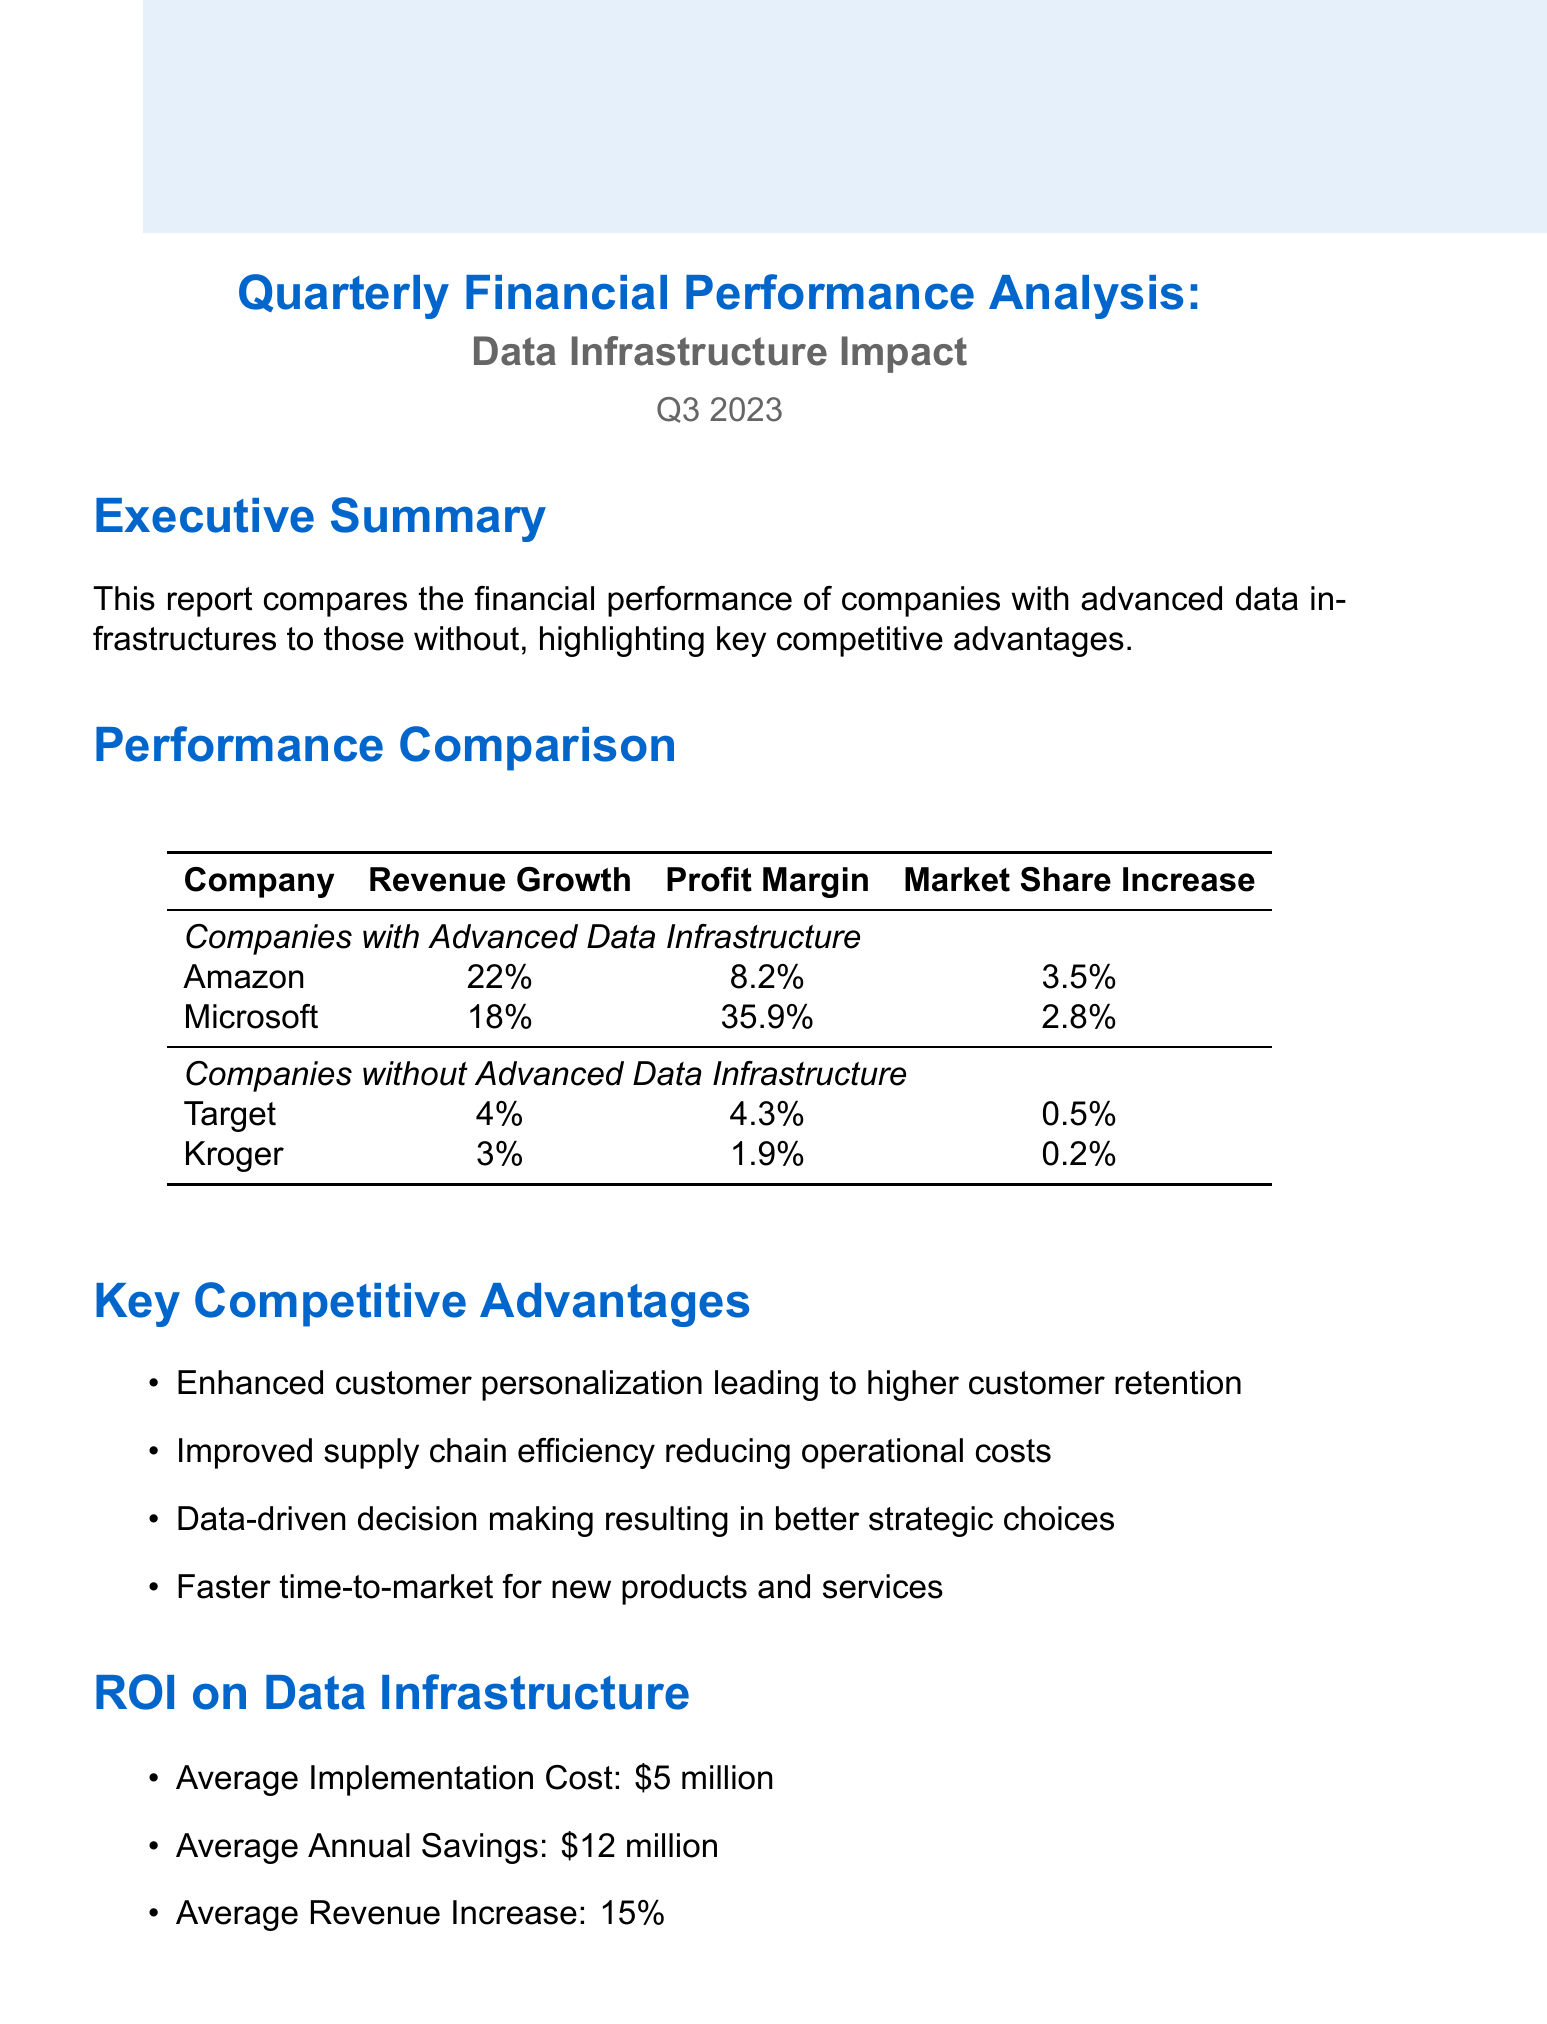What is the report title? The report title is explicitly stated at the beginning of the document.
Answer: Quarterly Financial Performance Analysis: Data Infrastructure Impact What is the revenue growth of Amazon? The revenue growth for Amazon is detailed in the Performance Comparison section of the document.
Answer: 22% What is the average implementation cost for data infrastructure? The average implementation cost is found in the ROI on Data Infrastructure section.
Answer: $5 million Which company has the highest profit margin? The highest profit margin is extracted from the performance comparison of companies with advanced data infrastructure.
Answer: Microsoft What competitive advantage relates to reducing operational costs? The competitive advantage related to operational costs can be found in the Key Competitive Advantages section.
Answer: Improved supply chain efficiency reducing operational costs By how much did Target's market share increase? Target's market share increase is listed in the Performance Comparison table.
Answer: 0.5% What is the average annual savings from implementing data infrastructure? This information is provided in the ROI on Data Infrastructure section.
Answer: $12 million Which company experienced a revenue growth of 3%? The company with 3% revenue growth is clearly mentioned in the Performance Comparison table.
Answer: Kroger 